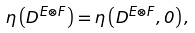<formula> <loc_0><loc_0><loc_500><loc_500>\eta \left ( D ^ { E \otimes F } \right ) = \eta \left ( D ^ { E \otimes F } , 0 \right ) ,</formula> 